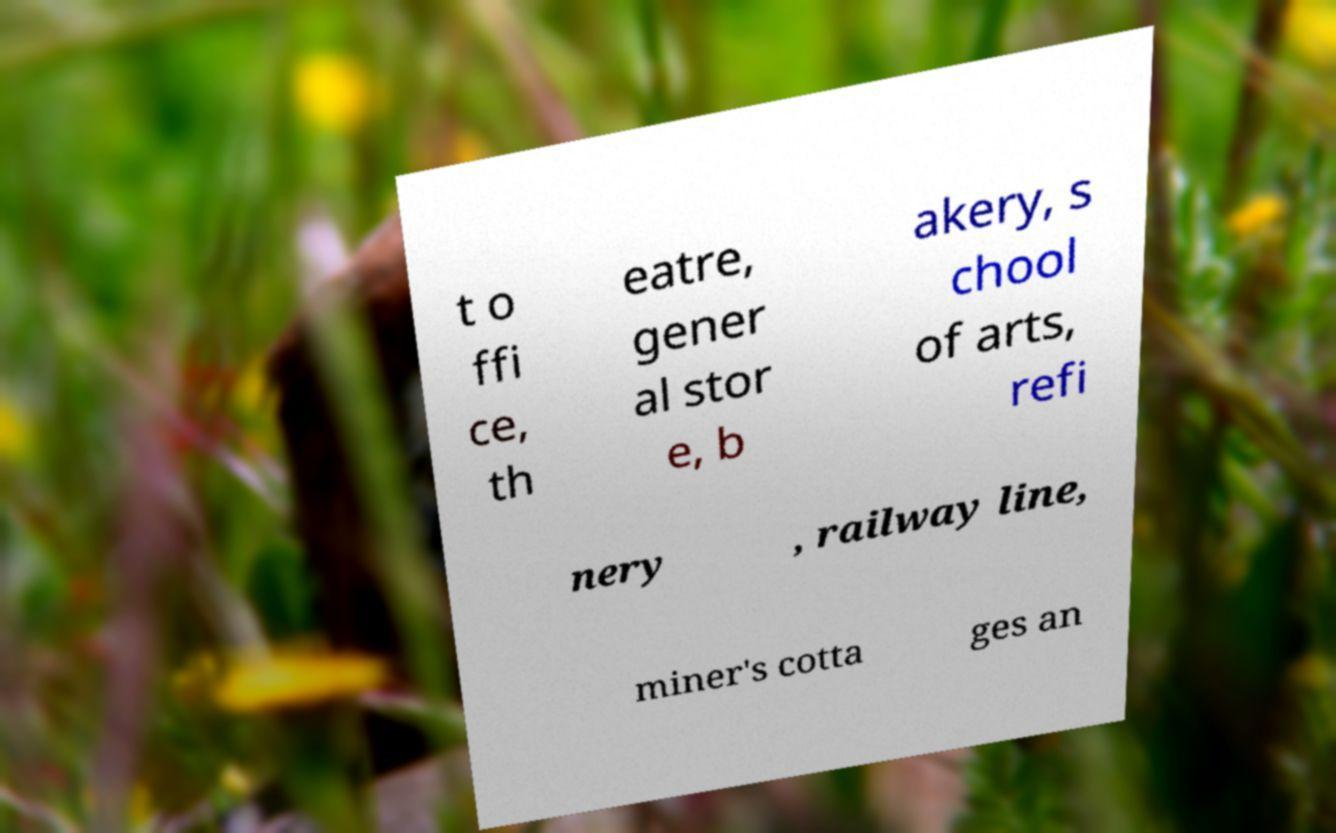Could you assist in decoding the text presented in this image and type it out clearly? t o ffi ce, th eatre, gener al stor e, b akery, s chool of arts, refi nery , railway line, miner's cotta ges an 